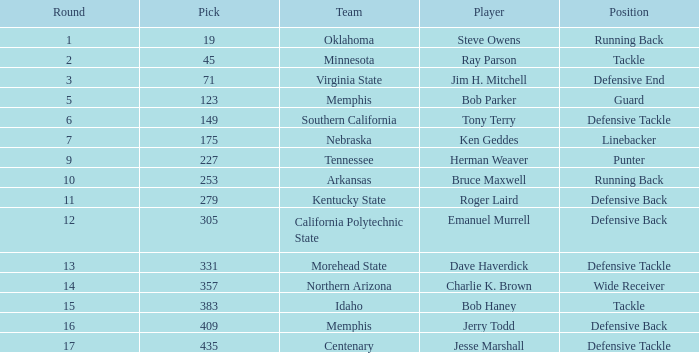What is the average pick of player jim h. mitchell? 71.0. 